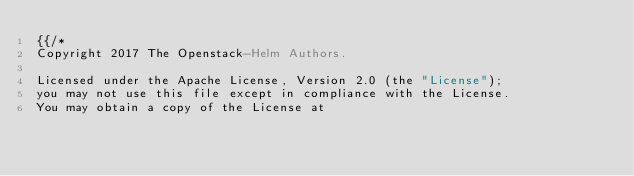Convert code to text. <code><loc_0><loc_0><loc_500><loc_500><_YAML_>{{/*
Copyright 2017 The Openstack-Helm Authors.

Licensed under the Apache License, Version 2.0 (the "License");
you may not use this file except in compliance with the License.
You may obtain a copy of the License at
</code> 